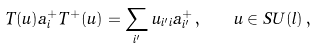Convert formula to latex. <formula><loc_0><loc_0><loc_500><loc_500>T ( u ) a _ { i } ^ { + } T ^ { + } ( u ) = \sum _ { i ^ { \prime } } u _ { i ^ { \prime } i } a _ { i ^ { \prime } } ^ { + } \, , \quad u \in S U ( l ) \, ,</formula> 